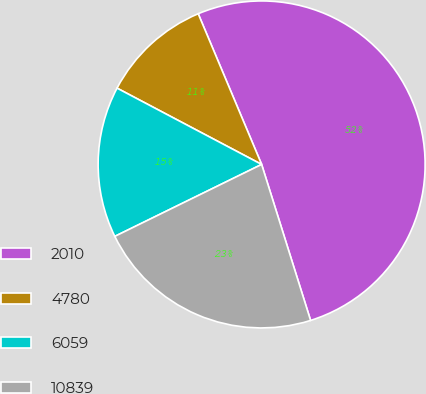Convert chart to OTSL. <chart><loc_0><loc_0><loc_500><loc_500><pie_chart><fcel>2010<fcel>4780<fcel>6059<fcel>10839<nl><fcel>51.5%<fcel>10.93%<fcel>14.98%<fcel>22.59%<nl></chart> 